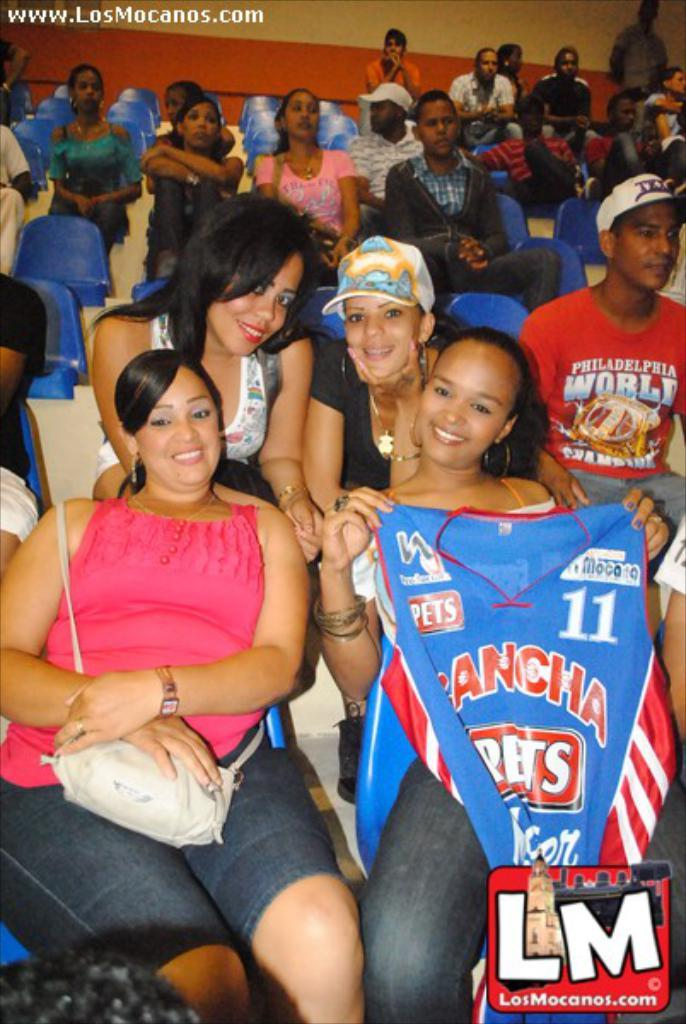<image>
Share a concise interpretation of the image provided. A stadium full of people and a woman among them is holding a shirt that says Rancha. 